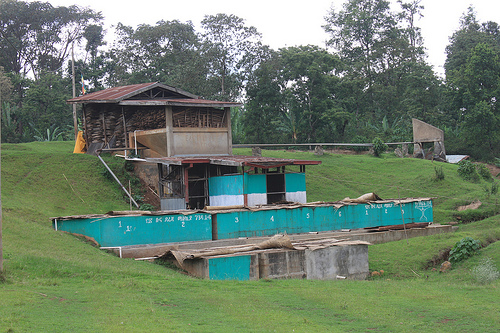<image>
Can you confirm if the meadow is next to the shack? Yes. The meadow is positioned adjacent to the shack, located nearby in the same general area. 